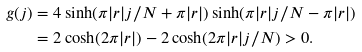Convert formula to latex. <formula><loc_0><loc_0><loc_500><loc_500>g ( j ) & = 4 \sinh ( \pi | r | j / N + \pi | r | ) \sinh ( \pi | r | j / N - \pi | r | ) \\ & = 2 \cosh ( 2 \pi | r | ) - 2 \cosh ( 2 \pi | r | j / N ) > 0 .</formula> 